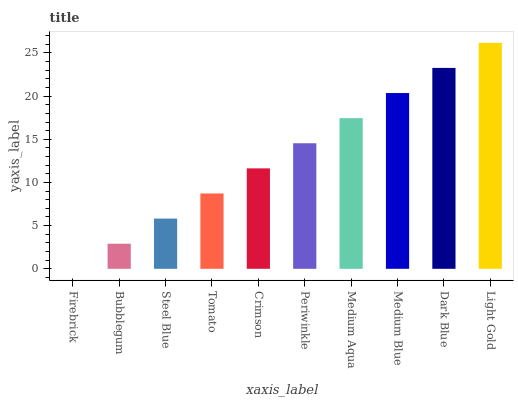Is Firebrick the minimum?
Answer yes or no. Yes. Is Light Gold the maximum?
Answer yes or no. Yes. Is Bubblegum the minimum?
Answer yes or no. No. Is Bubblegum the maximum?
Answer yes or no. No. Is Bubblegum greater than Firebrick?
Answer yes or no. Yes. Is Firebrick less than Bubblegum?
Answer yes or no. Yes. Is Firebrick greater than Bubblegum?
Answer yes or no. No. Is Bubblegum less than Firebrick?
Answer yes or no. No. Is Periwinkle the high median?
Answer yes or no. Yes. Is Crimson the low median?
Answer yes or no. Yes. Is Medium Aqua the high median?
Answer yes or no. No. Is Tomato the low median?
Answer yes or no. No. 